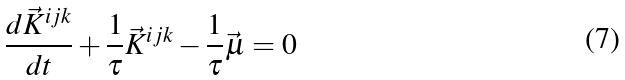<formula> <loc_0><loc_0><loc_500><loc_500>\frac { d \vec { K } ^ { i j k } } { d t } + \frac { 1 } { \tau } \vec { K } ^ { i j k } - \frac { 1 } { \tau } \vec { \mu } = 0</formula> 